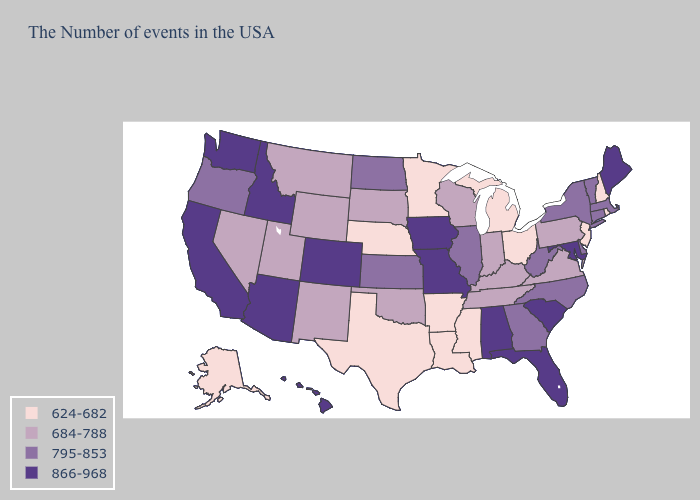Does Alabama have the highest value in the USA?
Keep it brief. Yes. Among the states that border Wyoming , which have the lowest value?
Short answer required. Nebraska. What is the value of Texas?
Write a very short answer. 624-682. Does New Hampshire have the lowest value in the USA?
Short answer required. Yes. Does Colorado have the highest value in the USA?
Give a very brief answer. Yes. What is the lowest value in states that border South Carolina?
Keep it brief. 795-853. Is the legend a continuous bar?
Answer briefly. No. Does Nevada have the lowest value in the USA?
Keep it brief. No. Does Massachusetts have a higher value than Connecticut?
Keep it brief. No. Name the states that have a value in the range 624-682?
Write a very short answer. Rhode Island, New Hampshire, New Jersey, Ohio, Michigan, Mississippi, Louisiana, Arkansas, Minnesota, Nebraska, Texas, Alaska. Which states hav the highest value in the MidWest?
Quick response, please. Missouri, Iowa. Among the states that border Ohio , which have the highest value?
Write a very short answer. West Virginia. How many symbols are there in the legend?
Concise answer only. 4. What is the value of Kentucky?
Quick response, please. 684-788. Name the states that have a value in the range 684-788?
Concise answer only. Pennsylvania, Virginia, Kentucky, Indiana, Tennessee, Wisconsin, Oklahoma, South Dakota, Wyoming, New Mexico, Utah, Montana, Nevada. 